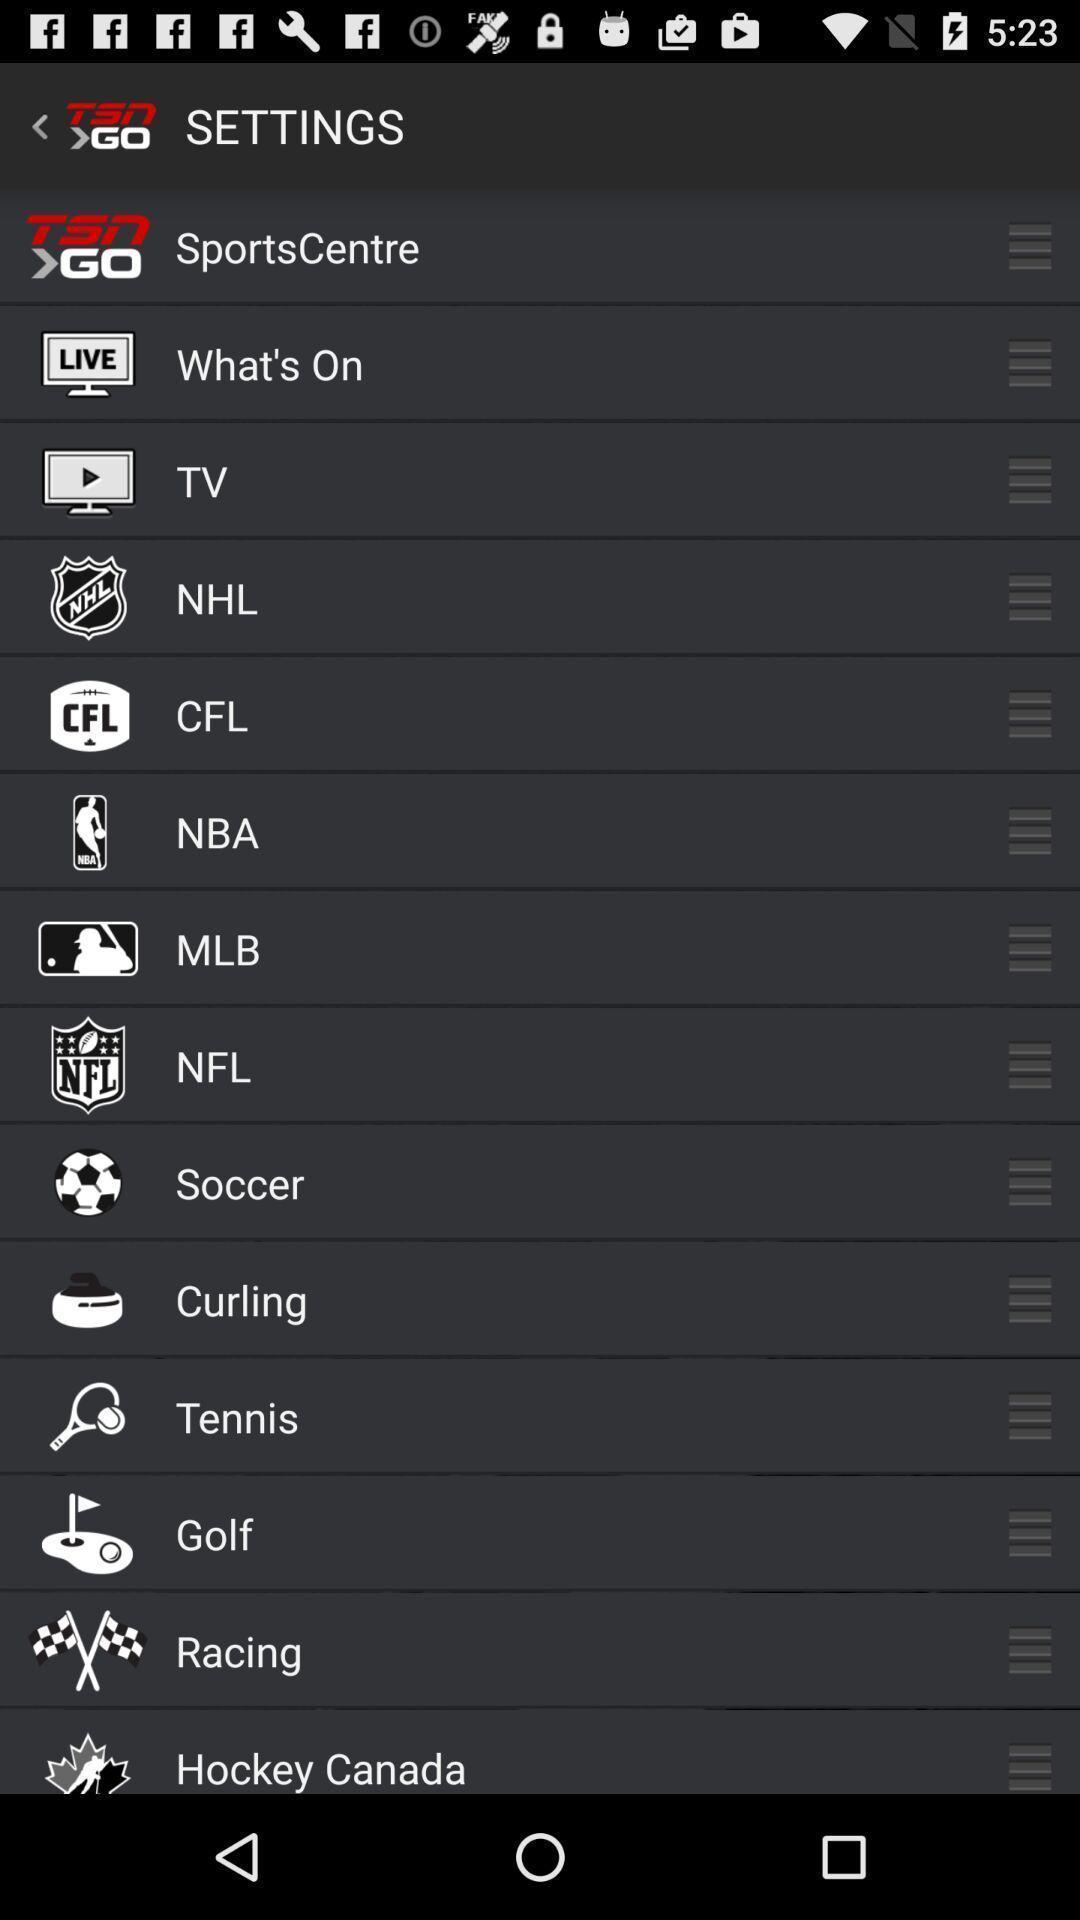Describe the key features of this screenshot. Setting page displaying various options. 